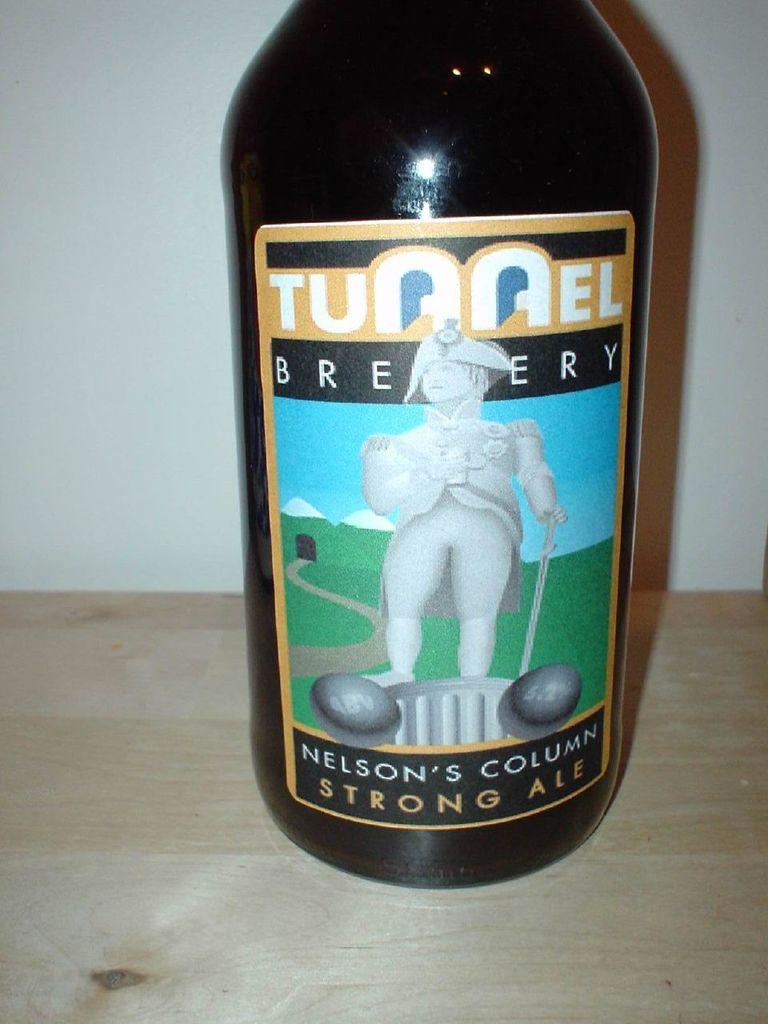What object is present in the image? There is a bottle in the image. What can be seen on the bottle? The bottle has a picture on it and text. Where is the bottle located in the image? The bottle is placed on a surface. What can be seen in the background of the image? There is a wall visible on the backside of the image. What type of feast is being prepared in the wilderness, as seen in the image? There is no feast or wilderness present in the image; it only features a bottle with a picture and text on it, placed on a surface with a wall visible in the background. 